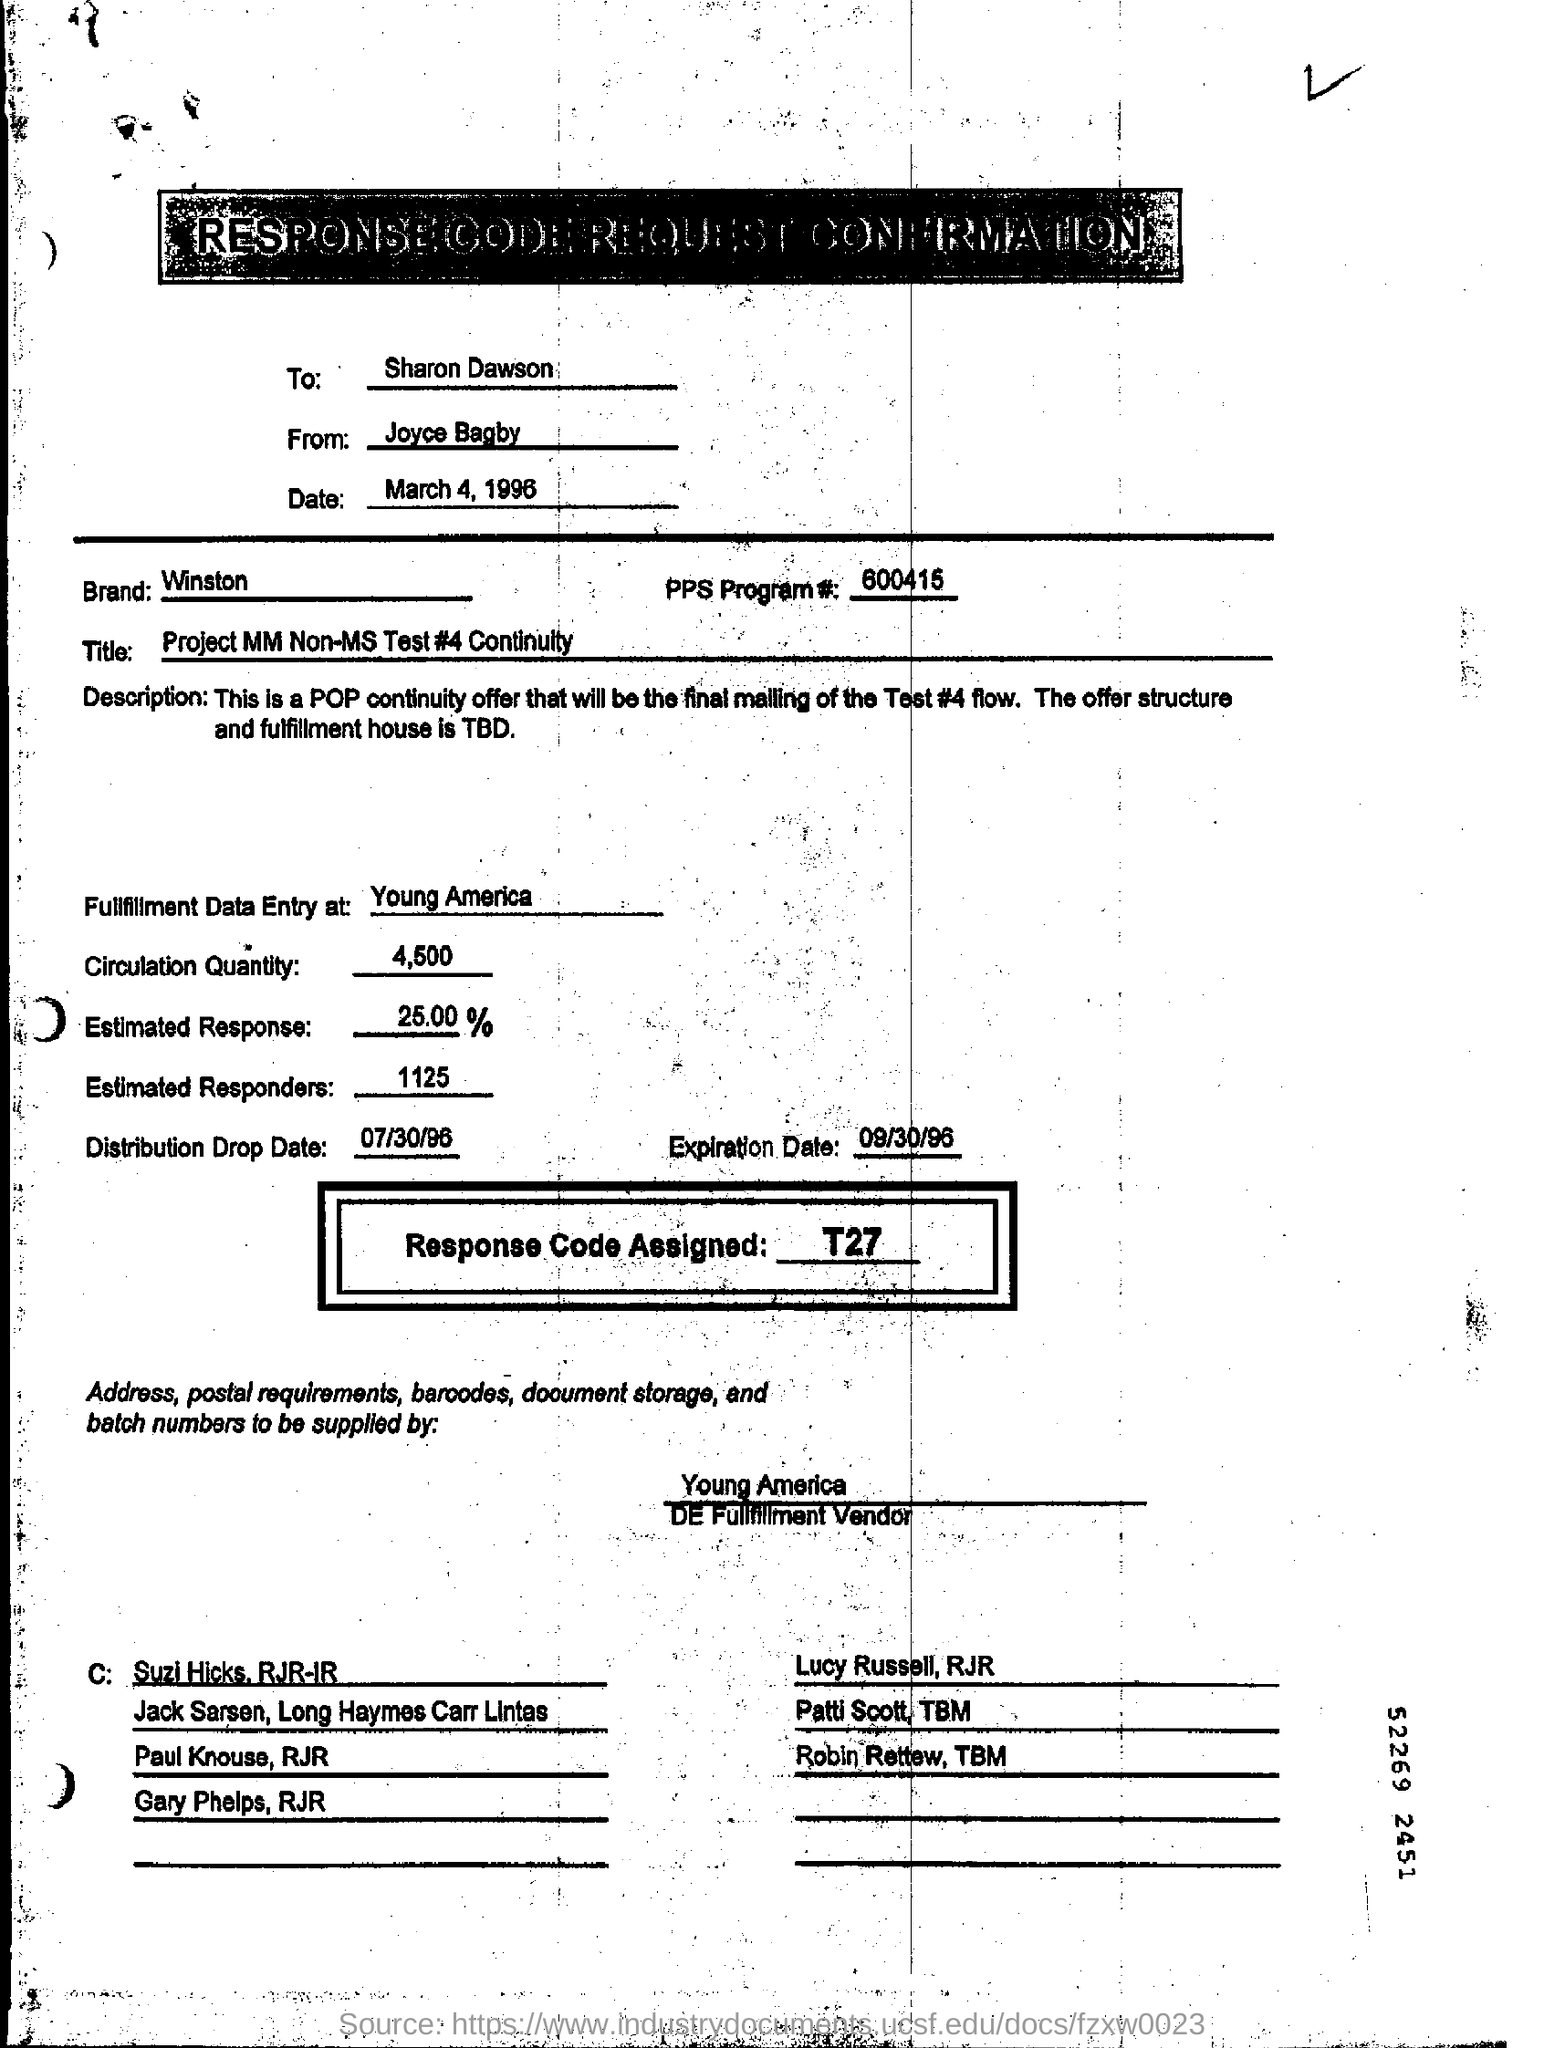Specify some key components in this picture. The distribution drop date is July 30, 1996. The estimated response is expected to be approximately 25.00%. The expiration date is September 30, 1996. The response code assigned is T27. The estimated number of responders is 1125. 